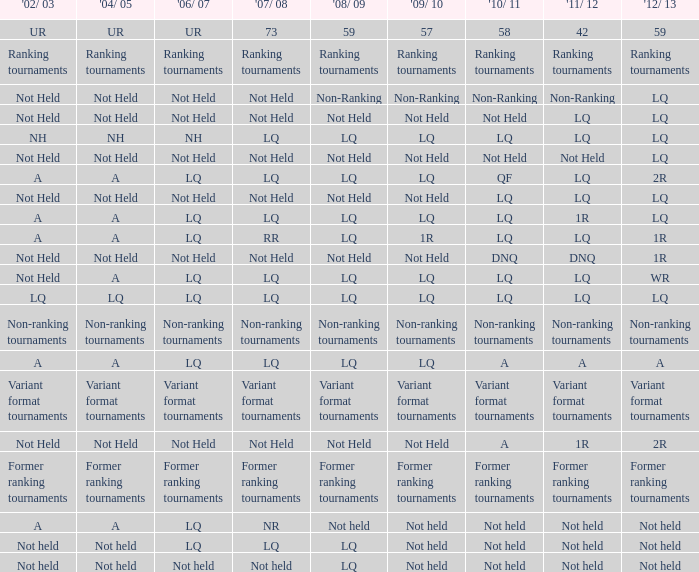Which ranking tournaments took place during the 2004/05 and 2008/09 seasons? Ranking tournaments. 